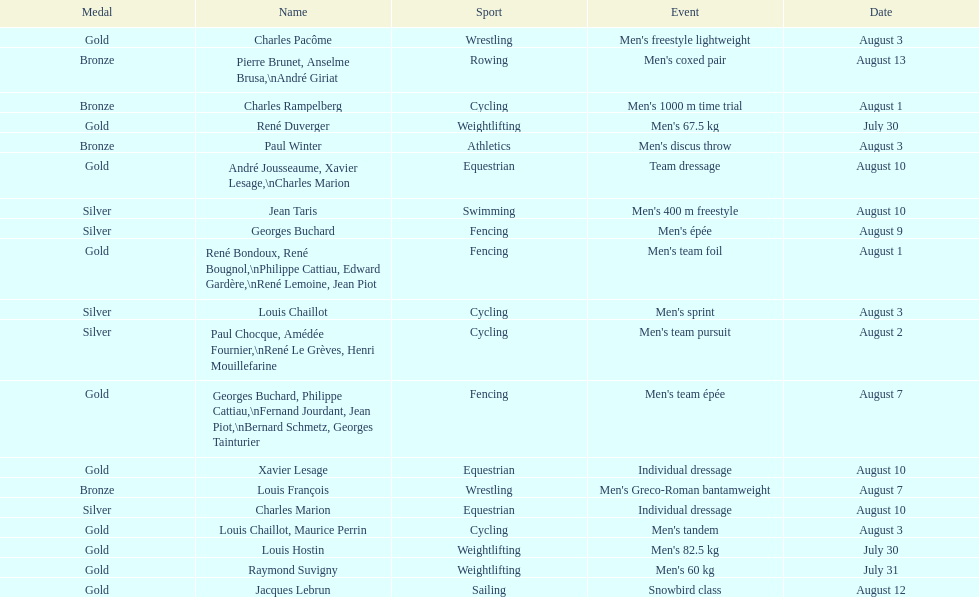Which event won the most medals? Cycling. 